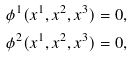Convert formula to latex. <formula><loc_0><loc_0><loc_500><loc_500>\phi ^ { 1 } ( x ^ { 1 } , x ^ { 2 } , x ^ { 3 } ) = 0 , \\ \phi ^ { 2 } ( x ^ { 1 } , x ^ { 2 } , x ^ { 3 } ) = 0 ,</formula> 